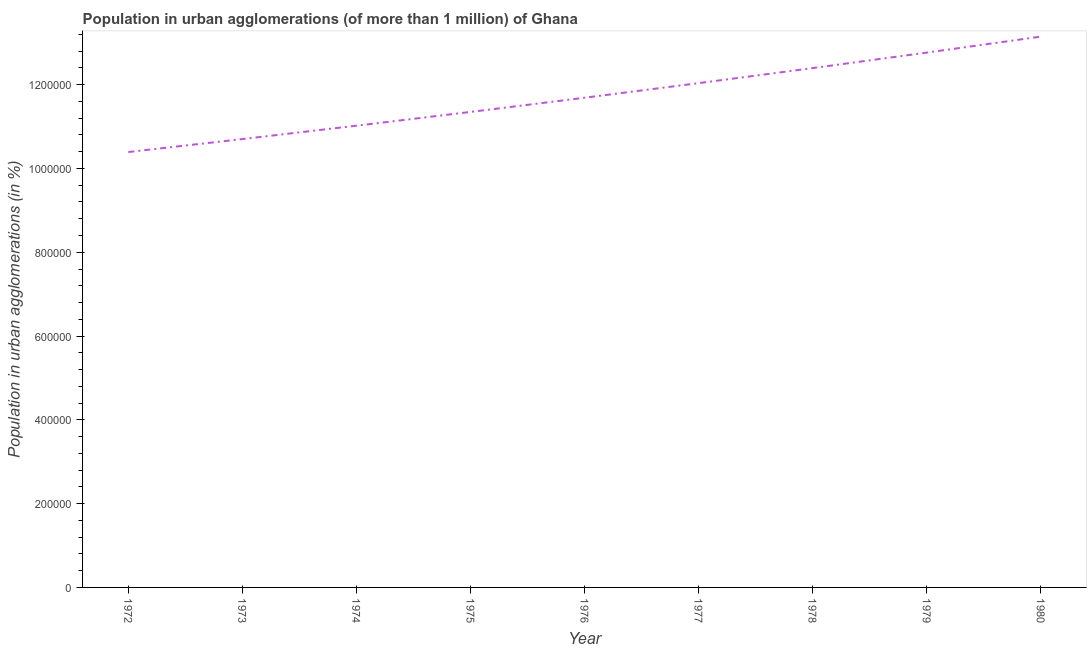What is the population in urban agglomerations in 1979?
Your answer should be very brief. 1.28e+06. Across all years, what is the maximum population in urban agglomerations?
Your answer should be very brief. 1.31e+06. Across all years, what is the minimum population in urban agglomerations?
Offer a very short reply. 1.04e+06. What is the sum of the population in urban agglomerations?
Your answer should be very brief. 1.06e+07. What is the difference between the population in urban agglomerations in 1972 and 1975?
Provide a short and direct response. -9.57e+04. What is the average population in urban agglomerations per year?
Your response must be concise. 1.17e+06. What is the median population in urban agglomerations?
Make the answer very short. 1.17e+06. In how many years, is the population in urban agglomerations greater than 840000 %?
Your answer should be compact. 9. What is the ratio of the population in urban agglomerations in 1974 to that in 1978?
Offer a very short reply. 0.89. Is the population in urban agglomerations in 1973 less than that in 1979?
Your answer should be very brief. Yes. What is the difference between the highest and the second highest population in urban agglomerations?
Your answer should be compact. 3.82e+04. Is the sum of the population in urban agglomerations in 1973 and 1974 greater than the maximum population in urban agglomerations across all years?
Your answer should be compact. Yes. What is the difference between the highest and the lowest population in urban agglomerations?
Offer a terse response. 2.76e+05. How many lines are there?
Give a very brief answer. 1. How many years are there in the graph?
Provide a short and direct response. 9. What is the difference between two consecutive major ticks on the Y-axis?
Provide a short and direct response. 2.00e+05. Are the values on the major ticks of Y-axis written in scientific E-notation?
Your answer should be very brief. No. Does the graph contain any zero values?
Your response must be concise. No. Does the graph contain grids?
Make the answer very short. No. What is the title of the graph?
Provide a short and direct response. Population in urban agglomerations (of more than 1 million) of Ghana. What is the label or title of the Y-axis?
Your answer should be compact. Population in urban agglomerations (in %). What is the Population in urban agglomerations (in %) of 1972?
Make the answer very short. 1.04e+06. What is the Population in urban agglomerations (in %) of 1973?
Ensure brevity in your answer.  1.07e+06. What is the Population in urban agglomerations (in %) of 1974?
Your answer should be compact. 1.10e+06. What is the Population in urban agglomerations (in %) in 1975?
Offer a terse response. 1.13e+06. What is the Population in urban agglomerations (in %) of 1976?
Give a very brief answer. 1.17e+06. What is the Population in urban agglomerations (in %) of 1977?
Your answer should be compact. 1.20e+06. What is the Population in urban agglomerations (in %) in 1978?
Offer a very short reply. 1.24e+06. What is the Population in urban agglomerations (in %) in 1979?
Provide a short and direct response. 1.28e+06. What is the Population in urban agglomerations (in %) in 1980?
Ensure brevity in your answer.  1.31e+06. What is the difference between the Population in urban agglomerations (in %) in 1972 and 1973?
Give a very brief answer. -3.09e+04. What is the difference between the Population in urban agglomerations (in %) in 1972 and 1974?
Provide a short and direct response. -6.28e+04. What is the difference between the Population in urban agglomerations (in %) in 1972 and 1975?
Offer a terse response. -9.57e+04. What is the difference between the Population in urban agglomerations (in %) in 1972 and 1976?
Provide a short and direct response. -1.30e+05. What is the difference between the Population in urban agglomerations (in %) in 1972 and 1977?
Offer a very short reply. -1.64e+05. What is the difference between the Population in urban agglomerations (in %) in 1972 and 1978?
Give a very brief answer. -2.00e+05. What is the difference between the Population in urban agglomerations (in %) in 1972 and 1979?
Offer a very short reply. -2.37e+05. What is the difference between the Population in urban agglomerations (in %) in 1972 and 1980?
Offer a very short reply. -2.76e+05. What is the difference between the Population in urban agglomerations (in %) in 1973 and 1974?
Provide a succinct answer. -3.19e+04. What is the difference between the Population in urban agglomerations (in %) in 1973 and 1975?
Your answer should be compact. -6.48e+04. What is the difference between the Population in urban agglomerations (in %) in 1973 and 1976?
Your answer should be compact. -9.87e+04. What is the difference between the Population in urban agglomerations (in %) in 1973 and 1977?
Make the answer very short. -1.33e+05. What is the difference between the Population in urban agglomerations (in %) in 1973 and 1978?
Offer a very short reply. -1.69e+05. What is the difference between the Population in urban agglomerations (in %) in 1973 and 1979?
Make the answer very short. -2.06e+05. What is the difference between the Population in urban agglomerations (in %) in 1973 and 1980?
Offer a terse response. -2.45e+05. What is the difference between the Population in urban agglomerations (in %) in 1974 and 1975?
Your answer should be compact. -3.29e+04. What is the difference between the Population in urban agglomerations (in %) in 1974 and 1976?
Your response must be concise. -6.68e+04. What is the difference between the Population in urban agglomerations (in %) in 1974 and 1977?
Offer a terse response. -1.02e+05. What is the difference between the Population in urban agglomerations (in %) in 1974 and 1978?
Your response must be concise. -1.38e+05. What is the difference between the Population in urban agglomerations (in %) in 1974 and 1979?
Provide a short and direct response. -1.75e+05. What is the difference between the Population in urban agglomerations (in %) in 1974 and 1980?
Your answer should be compact. -2.13e+05. What is the difference between the Population in urban agglomerations (in %) in 1975 and 1976?
Provide a short and direct response. -3.39e+04. What is the difference between the Population in urban agglomerations (in %) in 1975 and 1977?
Offer a very short reply. -6.87e+04. What is the difference between the Population in urban agglomerations (in %) in 1975 and 1978?
Provide a short and direct response. -1.05e+05. What is the difference between the Population in urban agglomerations (in %) in 1975 and 1979?
Your answer should be very brief. -1.42e+05. What is the difference between the Population in urban agglomerations (in %) in 1975 and 1980?
Offer a very short reply. -1.80e+05. What is the difference between the Population in urban agglomerations (in %) in 1976 and 1977?
Offer a terse response. -3.48e+04. What is the difference between the Population in urban agglomerations (in %) in 1976 and 1978?
Offer a terse response. -7.07e+04. What is the difference between the Population in urban agglomerations (in %) in 1976 and 1979?
Make the answer very short. -1.08e+05. What is the difference between the Population in urban agglomerations (in %) in 1976 and 1980?
Make the answer very short. -1.46e+05. What is the difference between the Population in urban agglomerations (in %) in 1977 and 1978?
Ensure brevity in your answer.  -3.59e+04. What is the difference between the Population in urban agglomerations (in %) in 1977 and 1979?
Keep it short and to the point. -7.29e+04. What is the difference between the Population in urban agglomerations (in %) in 1977 and 1980?
Offer a terse response. -1.11e+05. What is the difference between the Population in urban agglomerations (in %) in 1978 and 1979?
Ensure brevity in your answer.  -3.70e+04. What is the difference between the Population in urban agglomerations (in %) in 1978 and 1980?
Give a very brief answer. -7.52e+04. What is the difference between the Population in urban agglomerations (in %) in 1979 and 1980?
Your response must be concise. -3.82e+04. What is the ratio of the Population in urban agglomerations (in %) in 1972 to that in 1973?
Offer a very short reply. 0.97. What is the ratio of the Population in urban agglomerations (in %) in 1972 to that in 1974?
Your answer should be compact. 0.94. What is the ratio of the Population in urban agglomerations (in %) in 1972 to that in 1975?
Provide a short and direct response. 0.92. What is the ratio of the Population in urban agglomerations (in %) in 1972 to that in 1976?
Ensure brevity in your answer.  0.89. What is the ratio of the Population in urban agglomerations (in %) in 1972 to that in 1977?
Keep it short and to the point. 0.86. What is the ratio of the Population in urban agglomerations (in %) in 1972 to that in 1978?
Your answer should be very brief. 0.84. What is the ratio of the Population in urban agglomerations (in %) in 1972 to that in 1979?
Give a very brief answer. 0.81. What is the ratio of the Population in urban agglomerations (in %) in 1972 to that in 1980?
Keep it short and to the point. 0.79. What is the ratio of the Population in urban agglomerations (in %) in 1973 to that in 1975?
Make the answer very short. 0.94. What is the ratio of the Population in urban agglomerations (in %) in 1973 to that in 1976?
Your answer should be very brief. 0.92. What is the ratio of the Population in urban agglomerations (in %) in 1973 to that in 1977?
Your answer should be very brief. 0.89. What is the ratio of the Population in urban agglomerations (in %) in 1973 to that in 1978?
Keep it short and to the point. 0.86. What is the ratio of the Population in urban agglomerations (in %) in 1973 to that in 1979?
Offer a very short reply. 0.84. What is the ratio of the Population in urban agglomerations (in %) in 1973 to that in 1980?
Ensure brevity in your answer.  0.81. What is the ratio of the Population in urban agglomerations (in %) in 1974 to that in 1976?
Offer a terse response. 0.94. What is the ratio of the Population in urban agglomerations (in %) in 1974 to that in 1977?
Provide a succinct answer. 0.92. What is the ratio of the Population in urban agglomerations (in %) in 1974 to that in 1978?
Your response must be concise. 0.89. What is the ratio of the Population in urban agglomerations (in %) in 1974 to that in 1979?
Ensure brevity in your answer.  0.86. What is the ratio of the Population in urban agglomerations (in %) in 1974 to that in 1980?
Provide a short and direct response. 0.84. What is the ratio of the Population in urban agglomerations (in %) in 1975 to that in 1976?
Your answer should be compact. 0.97. What is the ratio of the Population in urban agglomerations (in %) in 1975 to that in 1977?
Provide a succinct answer. 0.94. What is the ratio of the Population in urban agglomerations (in %) in 1975 to that in 1978?
Offer a terse response. 0.92. What is the ratio of the Population in urban agglomerations (in %) in 1975 to that in 1979?
Make the answer very short. 0.89. What is the ratio of the Population in urban agglomerations (in %) in 1975 to that in 1980?
Ensure brevity in your answer.  0.86. What is the ratio of the Population in urban agglomerations (in %) in 1976 to that in 1977?
Provide a succinct answer. 0.97. What is the ratio of the Population in urban agglomerations (in %) in 1976 to that in 1978?
Your response must be concise. 0.94. What is the ratio of the Population in urban agglomerations (in %) in 1976 to that in 1979?
Offer a terse response. 0.92. What is the ratio of the Population in urban agglomerations (in %) in 1976 to that in 1980?
Ensure brevity in your answer.  0.89. What is the ratio of the Population in urban agglomerations (in %) in 1977 to that in 1979?
Offer a very short reply. 0.94. What is the ratio of the Population in urban agglomerations (in %) in 1977 to that in 1980?
Offer a terse response. 0.92. What is the ratio of the Population in urban agglomerations (in %) in 1978 to that in 1980?
Provide a succinct answer. 0.94. 